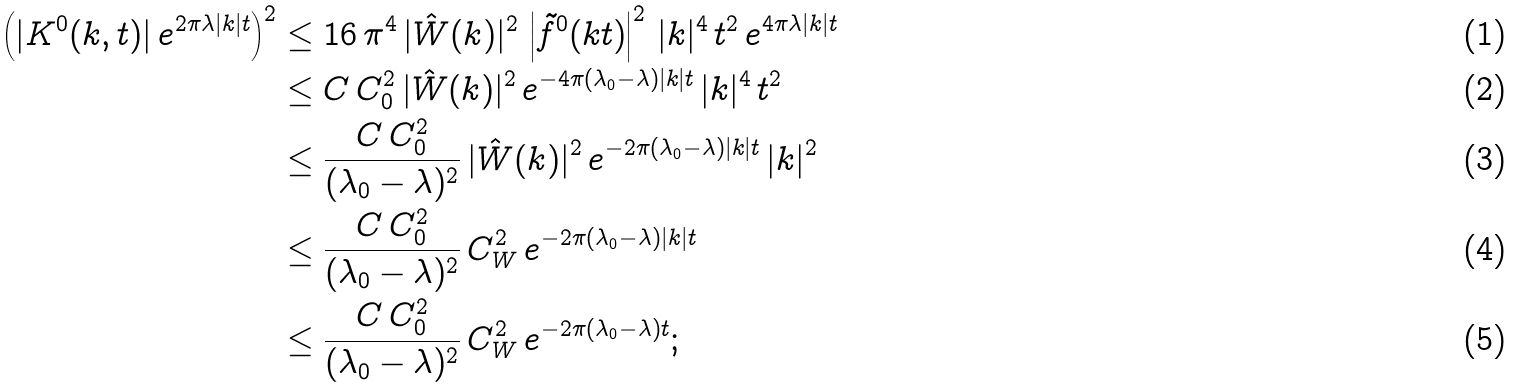<formula> <loc_0><loc_0><loc_500><loc_500>\left ( | K ^ { 0 } ( k , t ) | \, e ^ { 2 \pi \lambda | k | t } \right ) ^ { 2 } & \leq 1 6 \, \pi ^ { 4 } \, | \hat { W } ( k ) | ^ { 2 } \, \left | \tilde { f } ^ { 0 } ( k t ) \right | ^ { 2 } \, | k | ^ { 4 } \, t ^ { 2 } \, e ^ { 4 \pi \lambda | k | t } \\ & \leq C \, C _ { 0 } ^ { 2 } \, | \hat { W } ( k ) | ^ { 2 } \, e ^ { - 4 \pi ( \lambda _ { 0 } - \lambda ) | k | t } \, | k | ^ { 4 } \, t ^ { 2 } \\ & \leq \frac { C \, C _ { 0 } ^ { 2 } } { ( \lambda _ { 0 } - \lambda ) ^ { 2 } } \, | \hat { W } ( k ) | ^ { 2 } \, e ^ { - 2 \pi ( \lambda _ { 0 } - \lambda ) | k | t } \, | k | ^ { 2 } \\ & \leq \frac { C \, C _ { 0 } ^ { 2 } } { ( \lambda _ { 0 } - \lambda ) ^ { 2 } } \, C _ { W } ^ { 2 } \, e ^ { - 2 \pi ( \lambda _ { 0 } - \lambda ) | k | t } \\ & \leq \frac { C \, C _ { 0 } ^ { 2 } } { ( \lambda _ { 0 } - \lambda ) ^ { 2 } } \, C _ { W } ^ { 2 } \, e ^ { - 2 \pi ( \lambda _ { 0 } - \lambda ) t } ;</formula> 